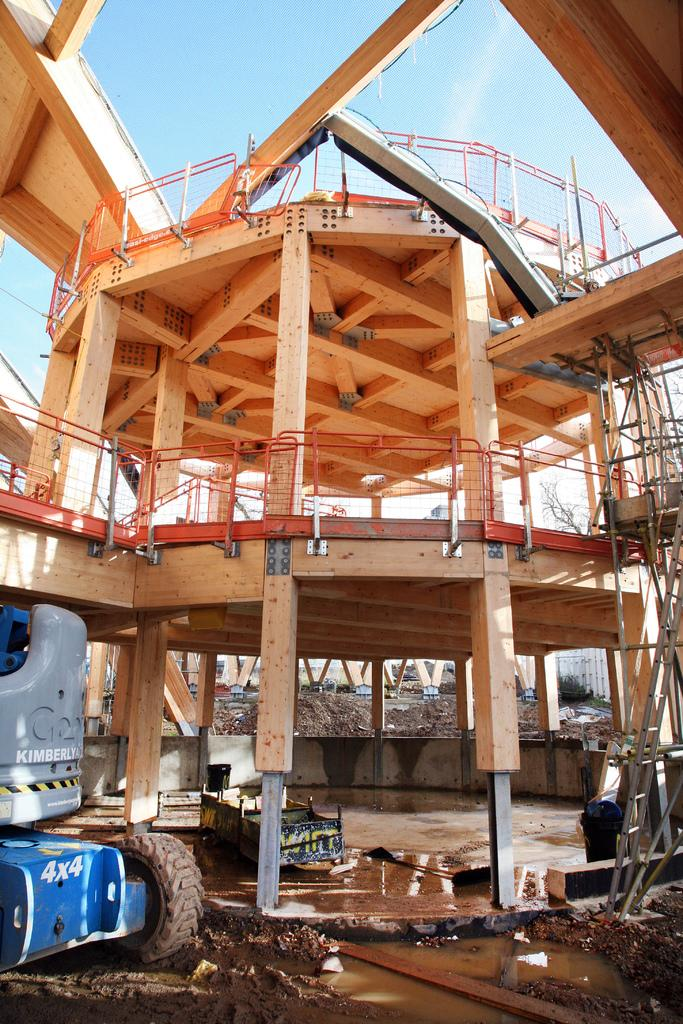What is the main subject of the image? There is a crane in the image. What is happening in the background of the image? There is a construction of a building in the background. What part of the natural environment is visible in the image? The sky is visible in the image. What type of exchange is taking place between the crane and the building in the image? There is no exchange taking place between the crane and the building in the image; the crane is simply present at the construction site. 